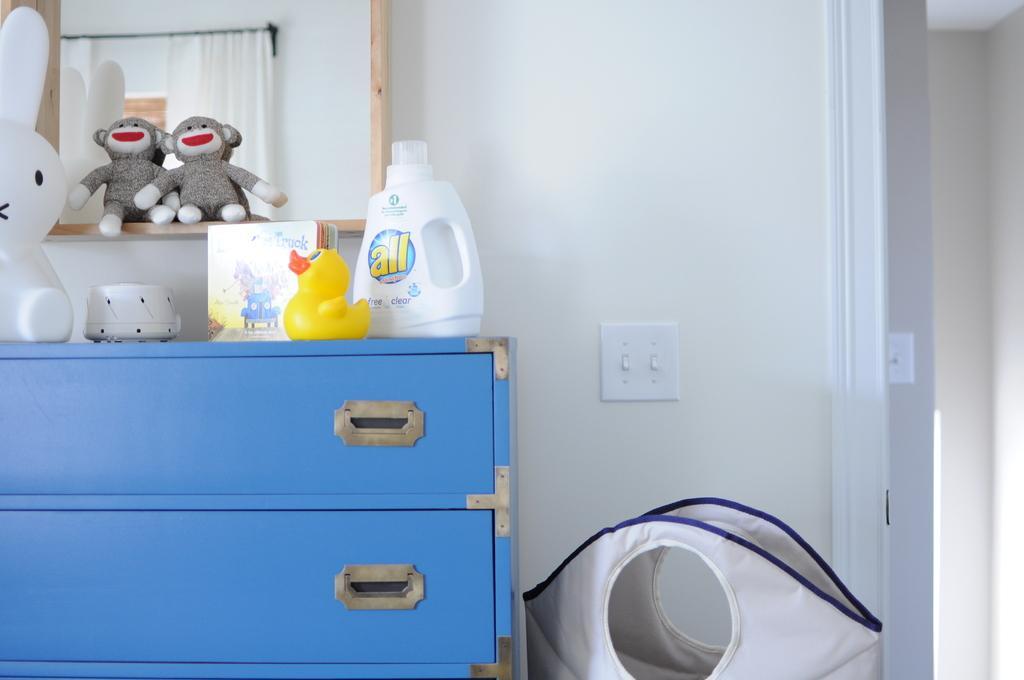Describe this image in one or two sentences. In this image we can see there is a cupboard. In the cupboard there are some toys and few objects are placed on it. In the background there is a wall. 